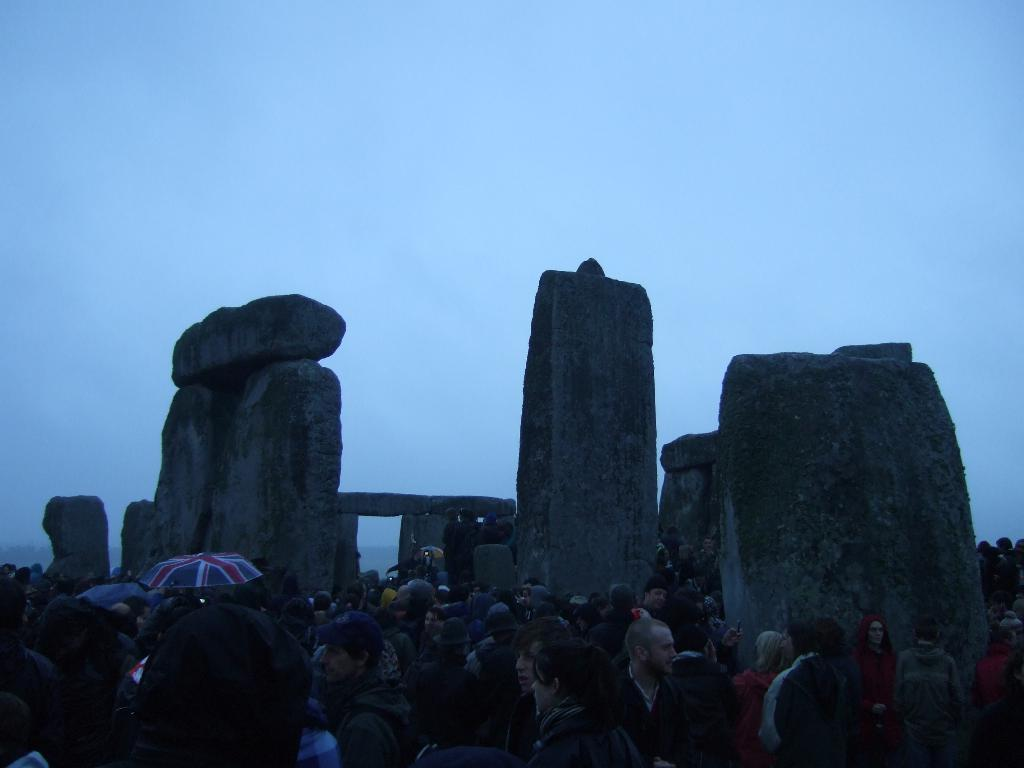How many people are present in the image? There are many people in the image. What type of natural feature can be seen in the image? There are rocks in the image. What objects are being used by the people in the image? There are umbrellas in the image. What is visible in the background of the image? The sky is visible in the background of the image. What language is being spoken by the people in the image? The image does not provide any information about the language being spoken by the people. 